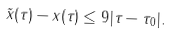<formula> <loc_0><loc_0><loc_500><loc_500>\| \tilde { x } ( \tau ) - x ( \tau ) \| \leq 9 | \tau - \tau _ { 0 } | .</formula> 